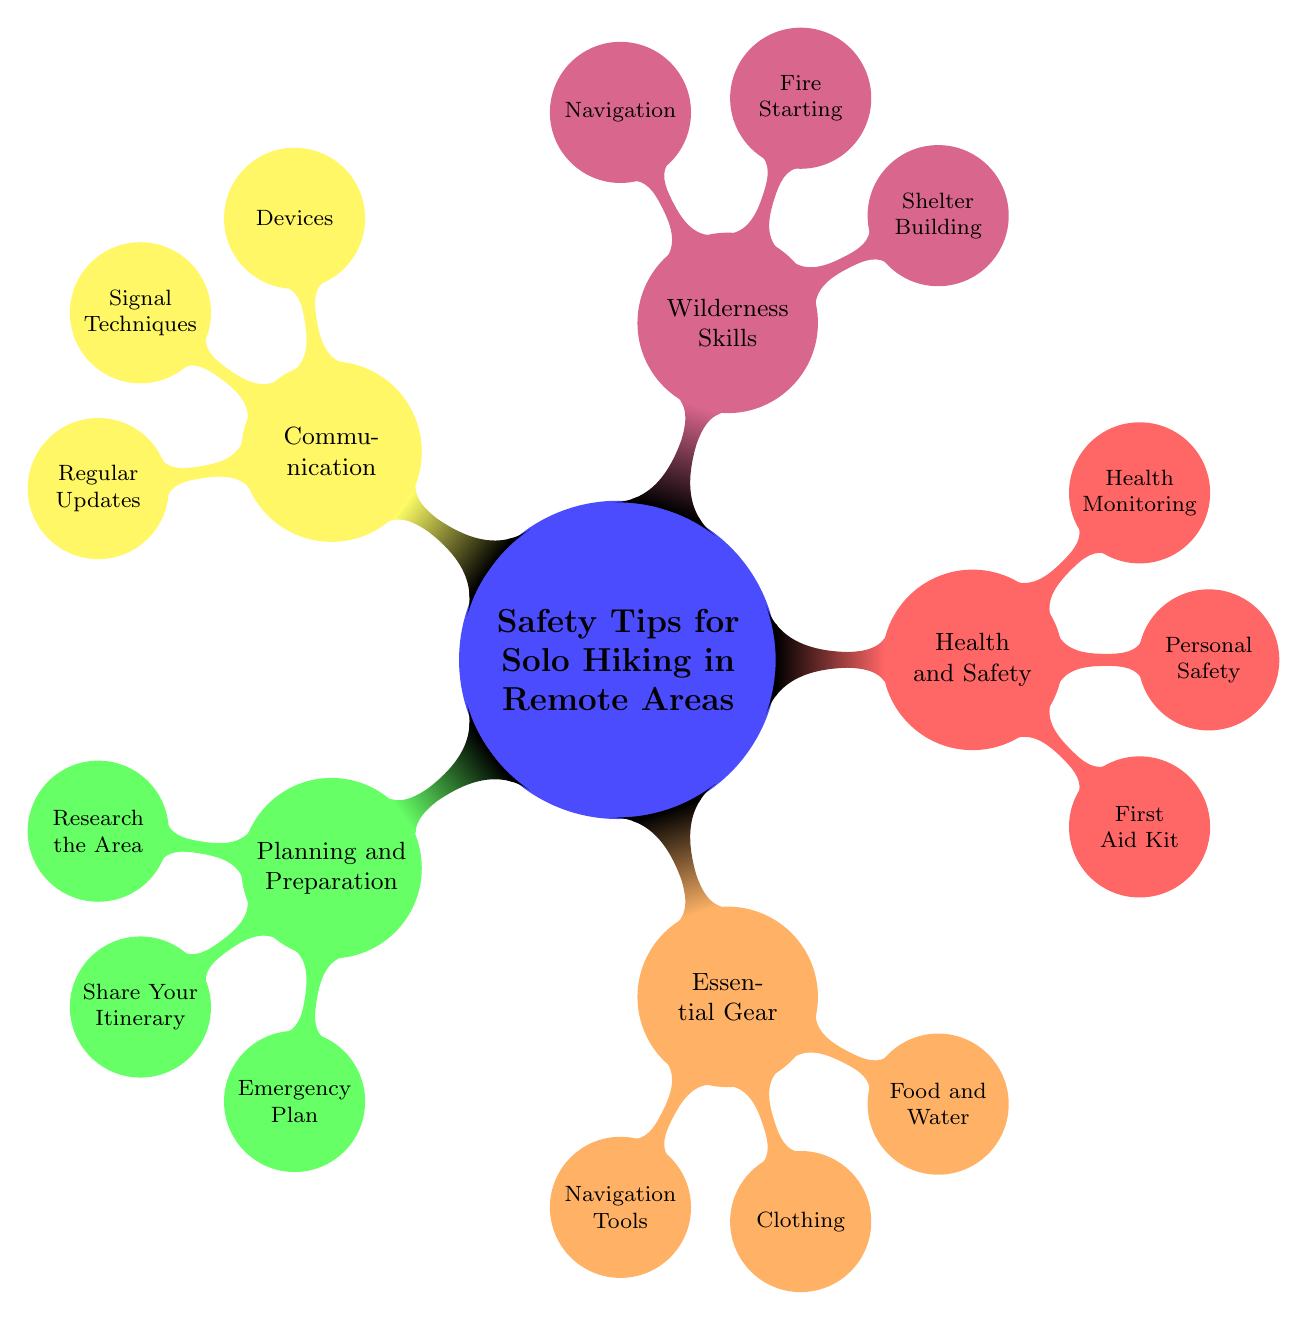What is one of the categories in the mind map? The mind map has several categories, one of which is "Planning and Preparation". This can be identified by examining the main branches that stem from the central node.
Answer: Planning and Preparation How many nodes are present under "Communication"? Under "Communication", there are three child nodes: "Devices", "Signal Techniques", and "Regular Updates". Counting these gives a total of three nodes.
Answer: 3 What is a suggested item for personal safety? Within the "Health and Safety" category, under the "Personal Safety" node, "Bear Spray" is listed as a suggested item for personal safety.
Answer: Bear Spray Which category includes "High-Energy Snacks"? "High-Energy Snacks" is found under the "Food and Water" node, which belongs to the "Essential Gear" category. Thus, "Essential Gear" is the category that includes it.
Answer: Essential Gear How many child nodes are associated with "Planning and Preparation"? "Planning and Preparation" contains three child nodes: "Research the Area", "Share Your Itinerary", and "Emergency Plan". Therefore, there are three associated child nodes.
Answer: 3 If someone wanted to signal for help, which node would be useful? The node "Signal Techniques" under the "Communication" category would provide useful information for signaling for help. This is determined by checking which nodes relate to signaling.
Answer: Signal Techniques What is included in the "Emergency Plan"? Under the "Emergency Plan" node, the items listed include "Signal Flares", "Whistle", and "Emergency Contacts", providing a clear overview of what should be prepared.
Answer: Signal Flares, Whistle, Emergency Contacts Which essential gear is suggested for navigation? The "Navigation Tools" node under "Essential Gear" includes "GPS Device", "Compass", and "Maps". Any of these items can be considered essential for navigation.
Answer: GPS Device 